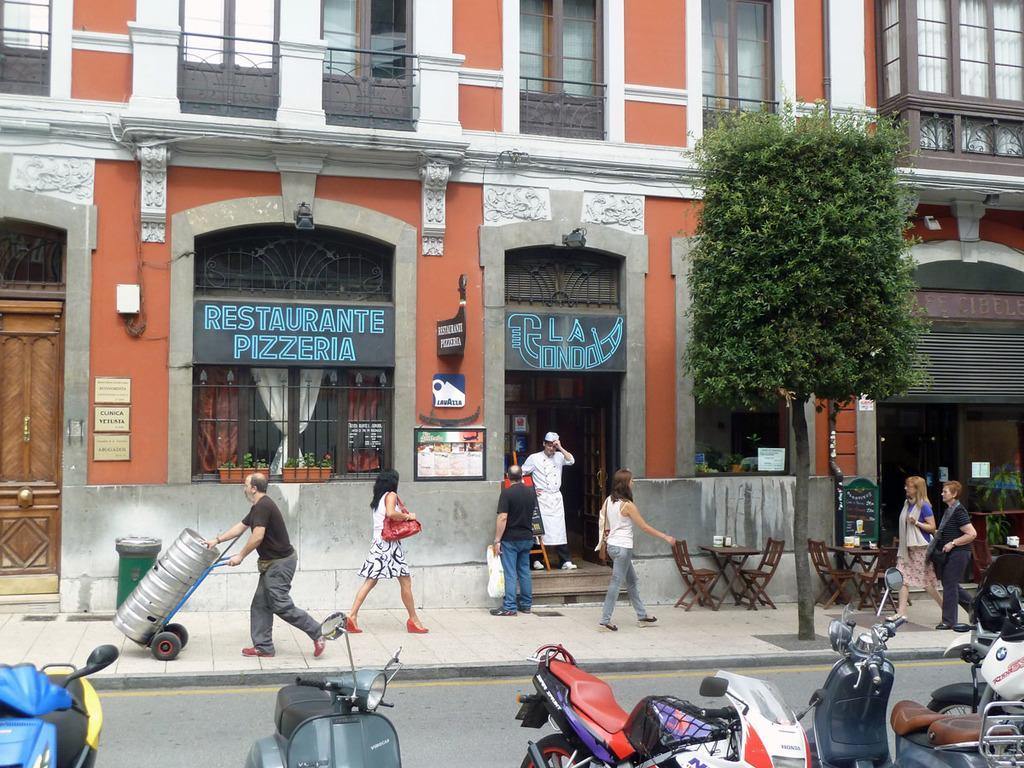In one or two sentences, can you explain what this image depicts? In this image in front there are vehicles on the road. There are people walking on the pavement. There are tables. On top of it there are a few objects. There are chairs. There is a tree. There are flower pots. There is a trash can. In the background of the image there are buildings. 